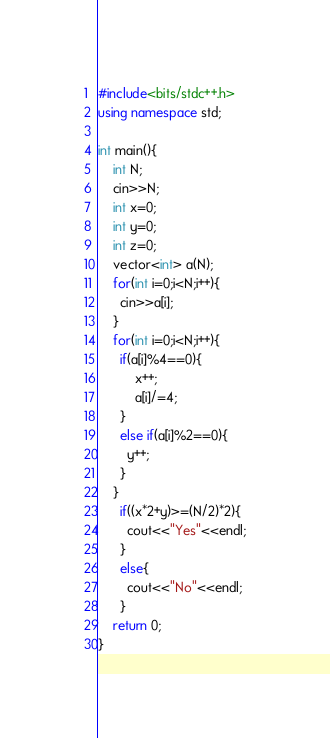Convert code to text. <code><loc_0><loc_0><loc_500><loc_500><_C++_>#include<bits/stdc++.h>
using namespace std;

int main(){
    int N;
    cin>>N;
    int x=0;
    int y=0;
    int z=0;
    vector<int> a(N);
    for(int i=0;i<N;i++){
      cin>>a[i];
    }
    for(int i=0;i<N;i++){
      if(a[i]%4==0){
          x++;
          a[i]/=4;
      }
      else if(a[i]%2==0){
        y++;
      }
    }
      if((x*2+y)>=(N/2)*2){
        cout<<"Yes"<<endl;
      }
      else{
        cout<<"No"<<endl;
      }
    return 0;
}


</code> 